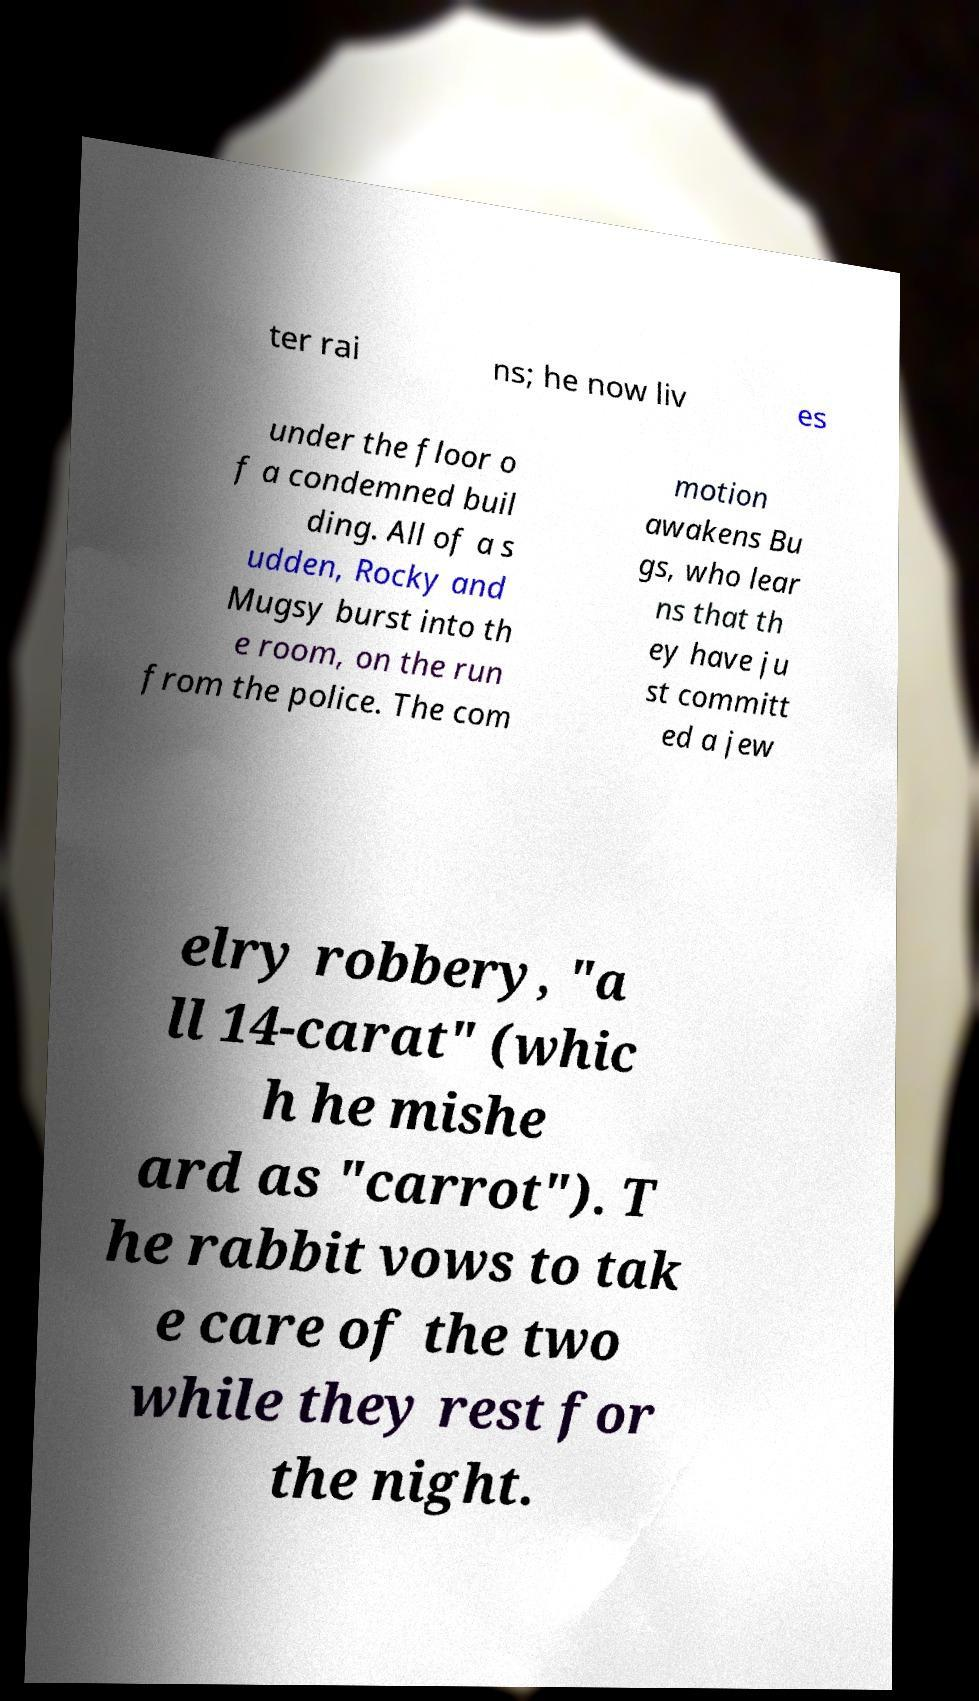Could you extract and type out the text from this image? ter rai ns; he now liv es under the floor o f a condemned buil ding. All of a s udden, Rocky and Mugsy burst into th e room, on the run from the police. The com motion awakens Bu gs, who lear ns that th ey have ju st committ ed a jew elry robbery, "a ll 14-carat" (whic h he mishe ard as "carrot"). T he rabbit vows to tak e care of the two while they rest for the night. 